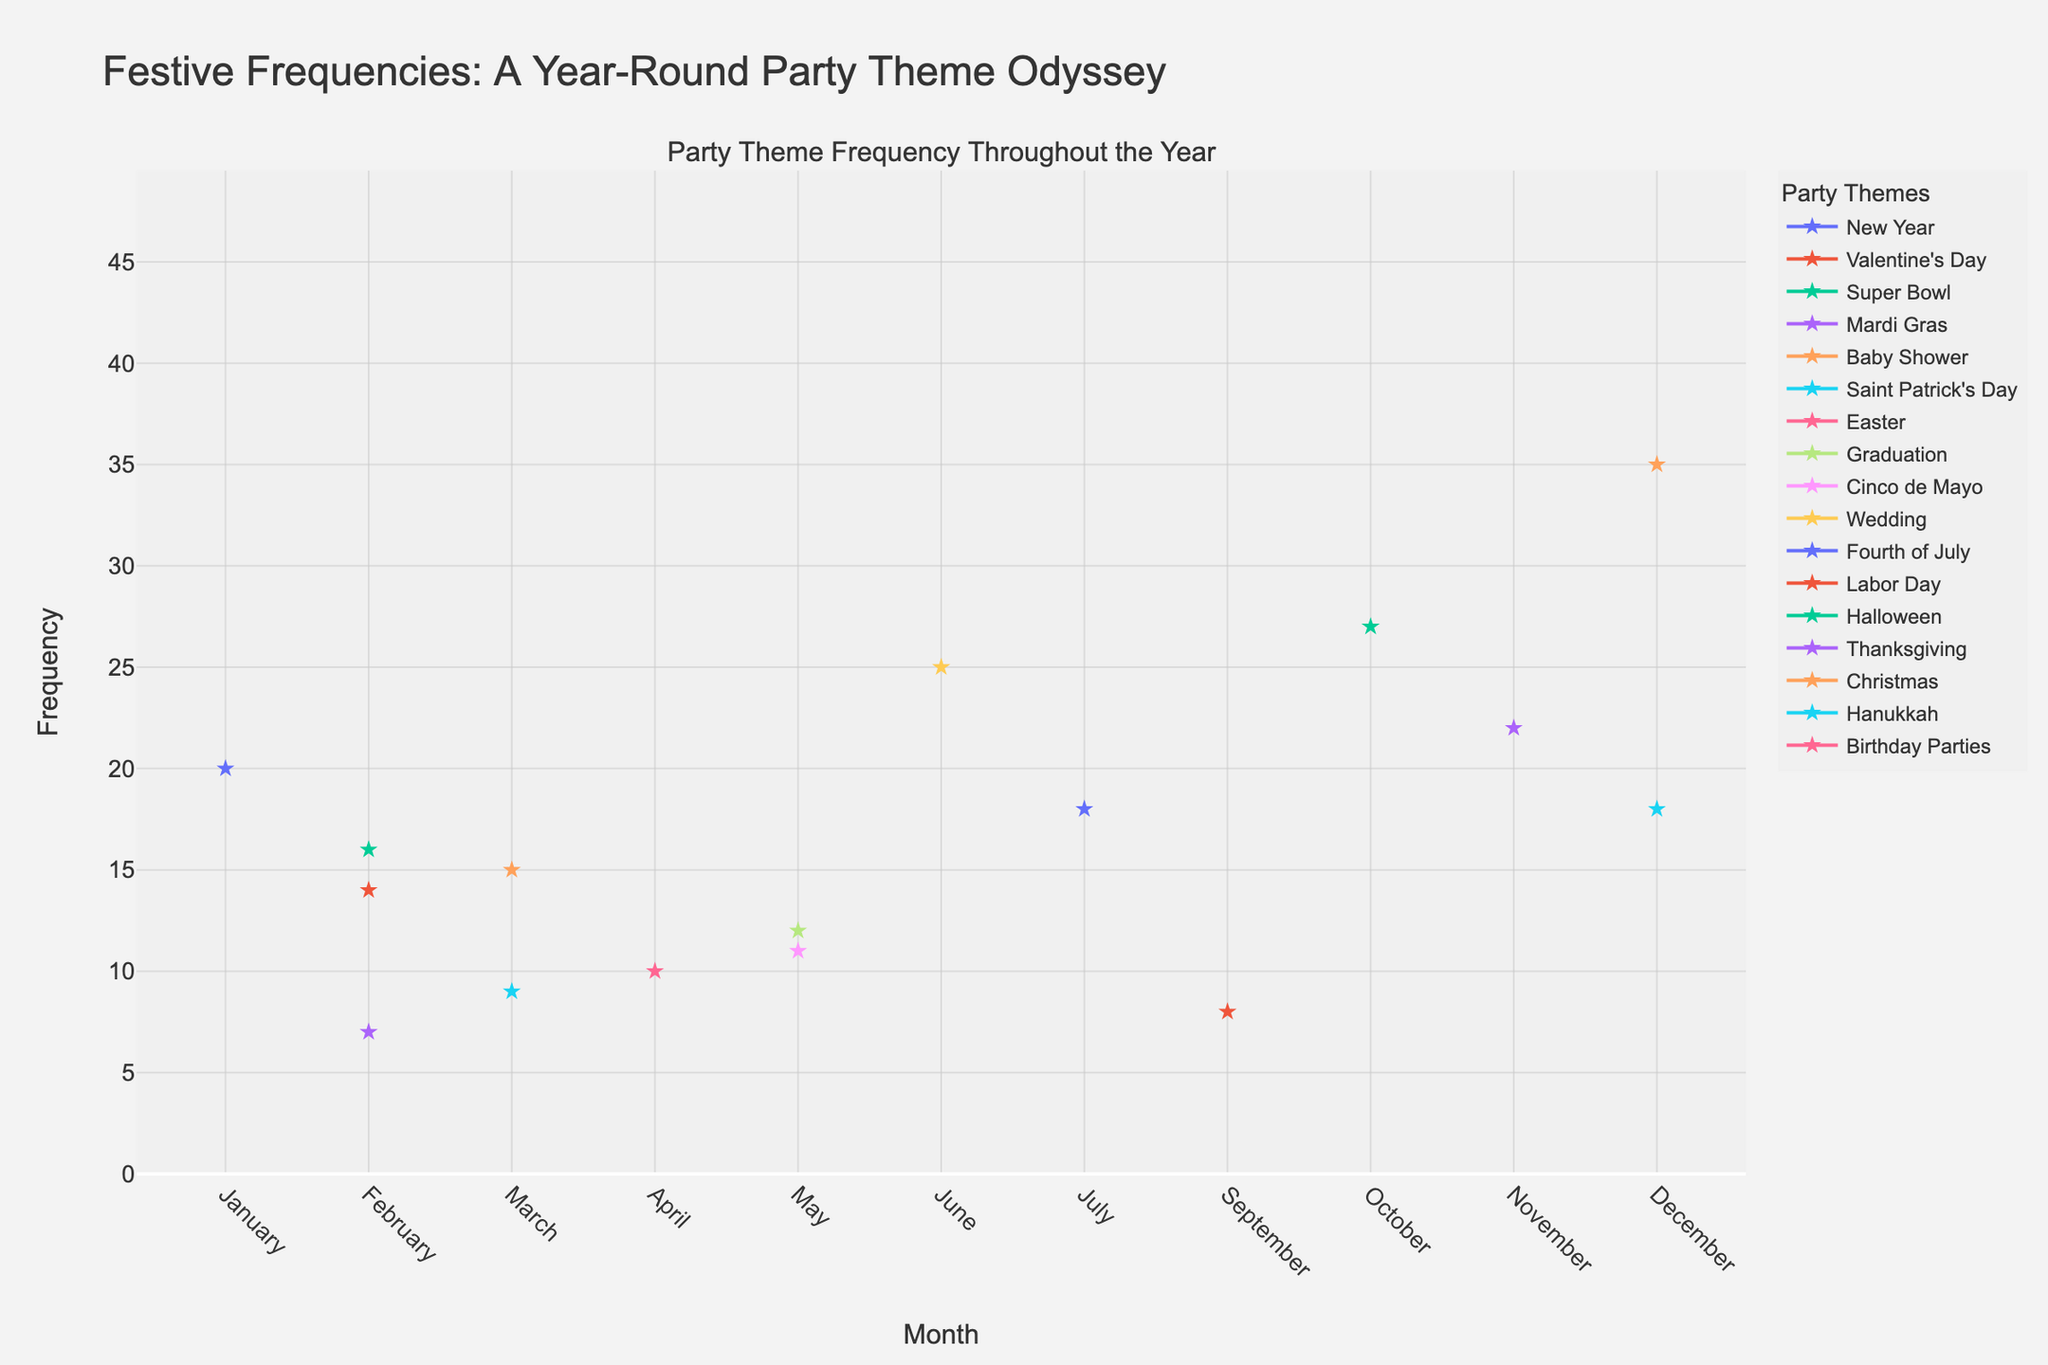What is the title of the density plot? The title of the plot is prominently displayed at the top of the figure, reading "Festive Frequencies: A Year-Round Party Theme Odyssey". This can be directly observed from the visual information presented in the plot.
Answer: Festive Frequencies: A Year-Round Party Theme Odyssey Which month has the highest frequency for Christmas-themed parties? By examining the plot, we notice that each party theme has a corresponding line. The line for Christmas peaks in December. The frequency value at this peak is the highest among other themes organized in December. The frequency value for the Christmas theme in December is specifically annotated as 35.
Answer: December How does the frequency of Halloween-themed parties in October compare to Thanksgiving-themed parties in November? To answer this, look at the peak points for Halloween and Thanksgiving themes. Halloween has a peak of 27 in October, while Thanksgiving has a peak of 22 in November. Comparing these, the Halloween theme has a higher frequency.
Answer: Halloween (27) > Thanksgiving (22) What is the average frequency of parties themed around Valentine's Day, Super Bowl, and Mardi Gras in February? First, identify the frequencies in February: Valentine's Day (14), Super Bowl (16), and Mardi Gras (7). Sum these values: 14 + 16 + 7 = 37. Next, divide by the number of themes (3): 37 / 3 = 12.33.
Answer: 12.33 Which theme has the highest overall frequency throughout the year? Examine the plot to identify the theme with the highest data point. Birthday Parties are denoted to hold the highest frequency, with a value of 45, universally distributed across all months.
Answer: Birthday Parties Between Wedding-themed parties in June and Graduation-themed parties in May, which has a higher frequency? First, find the frequency for Wedding in June (25) and for Graduation in May (12). By comparing these values, the frequency of Wedding-themed parties is higher than Graduation-themed parties.
Answer: Wedding (25) > Graduation (12) Which month's themes appear to have the least combined total frequency? To solve this, sum the frequencies of all themes for each month and identify the month with the lowest sum. Labor Day in September stands out as the lowest individual frequency with a frequency of 8, and it doesn't seem to have other overlapping themes. Thus, the combined total for September is the lowest.
Answer: September Calculate the combined frequency of all themes organized in December. The relevant themes are Christmas (35) and Hanukkah (18). Adding their frequencies provides the combined total: 35 + 18 = 53.
Answer: 53 What is the range of frequencies depicted in the plot? To find the range, identify the highest and lowest frequency values. The highest frequency is 45 (Birthday Parties, year-round). The lowest is 7 (Mardi Gras, February). Subtracting these gives the range: 45 - 7 = 38.
Answer: 38 What is the frequency difference between Halloween in October and New Year in January? Locate the frequencies: Halloween (27) in October and New Year (20) in January. The difference is calculated as: 27 - 20 = 7.
Answer: 7 